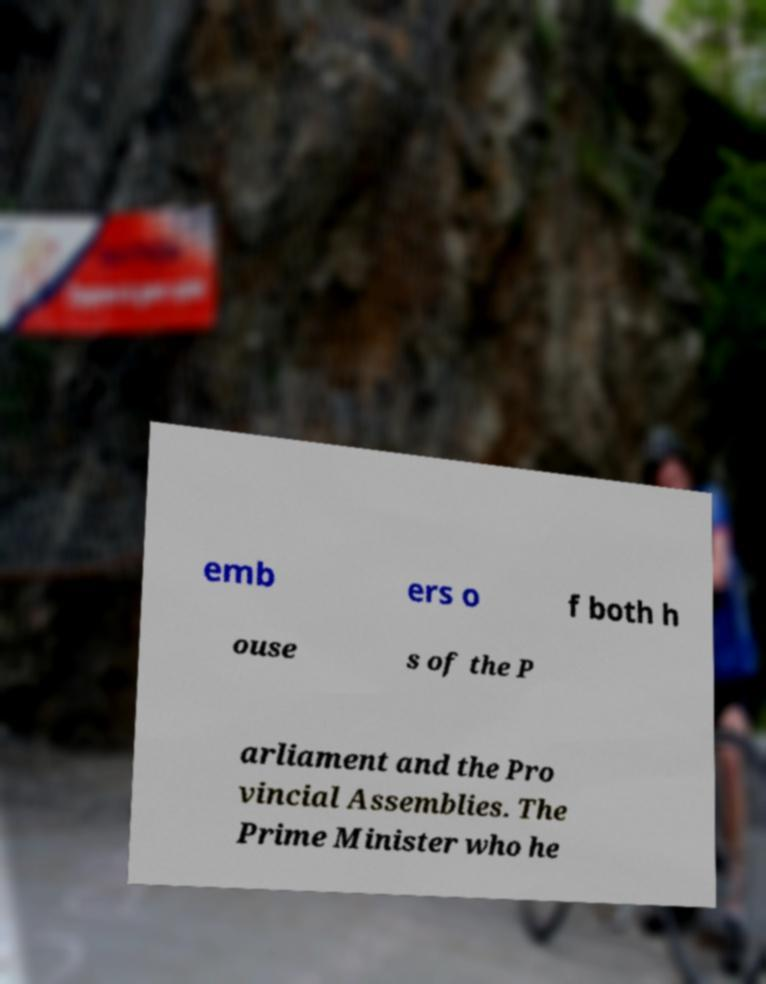I need the written content from this picture converted into text. Can you do that? emb ers o f both h ouse s of the P arliament and the Pro vincial Assemblies. The Prime Minister who he 